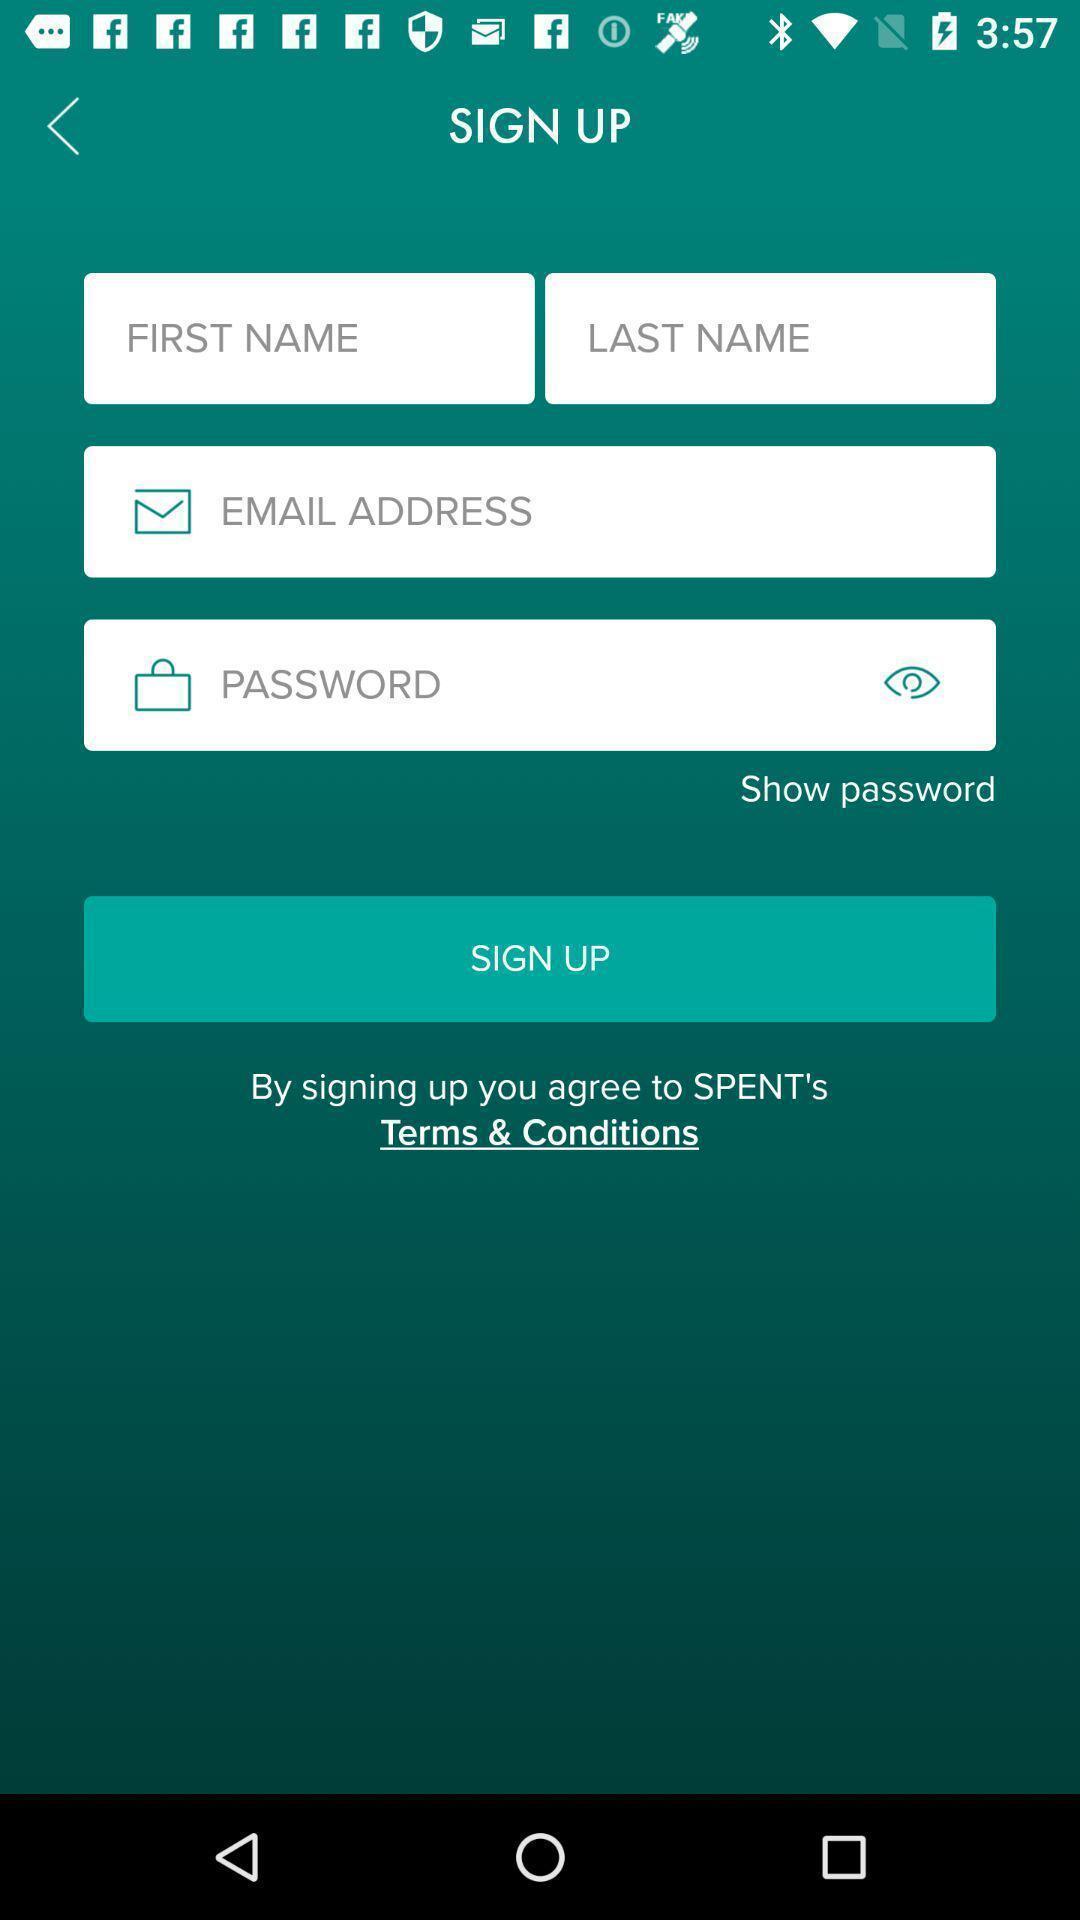Describe the content in this image. Sign-up page. 